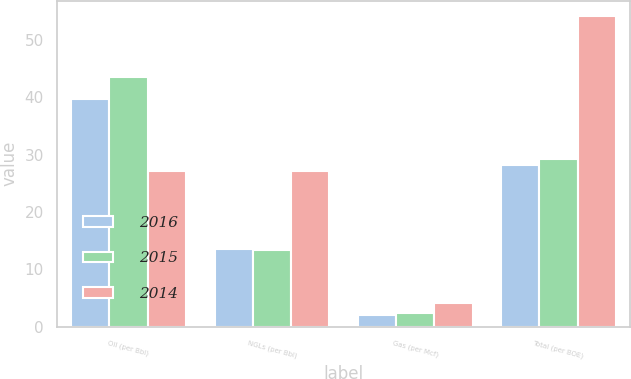Convert chart to OTSL. <chart><loc_0><loc_0><loc_500><loc_500><stacked_bar_chart><ecel><fcel>Oil (per Bbl)<fcel>NGLs (per Bbl)<fcel>Gas (per Mcf)<fcel>Total (per BOE)<nl><fcel>2016<fcel>39.65<fcel>13.49<fcel>2.11<fcel>28.25<nl><fcel>2015<fcel>43.55<fcel>13.31<fcel>2.4<fcel>29.25<nl><fcel>2014<fcel>27.06<fcel>27.06<fcel>4.1<fcel>54.11<nl></chart> 